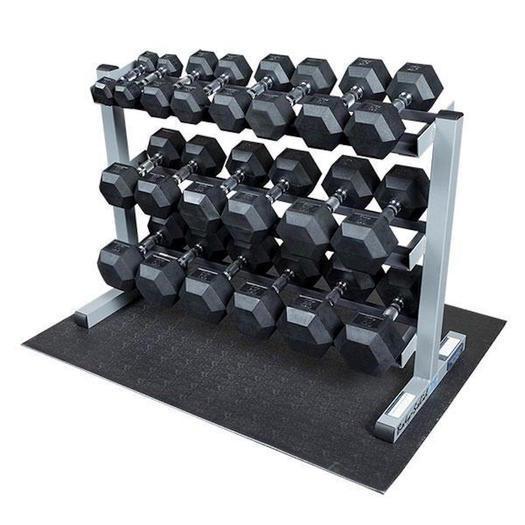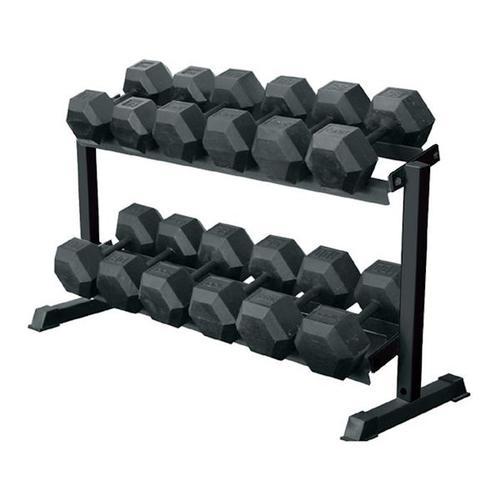The first image is the image on the left, the second image is the image on the right. Given the left and right images, does the statement "The right image contains sets of weights stacked into three rows." hold true? Answer yes or no. No. The first image is the image on the left, the second image is the image on the right. For the images shown, is this caption "The weights on the rack in the image on the left are round." true? Answer yes or no. No. 